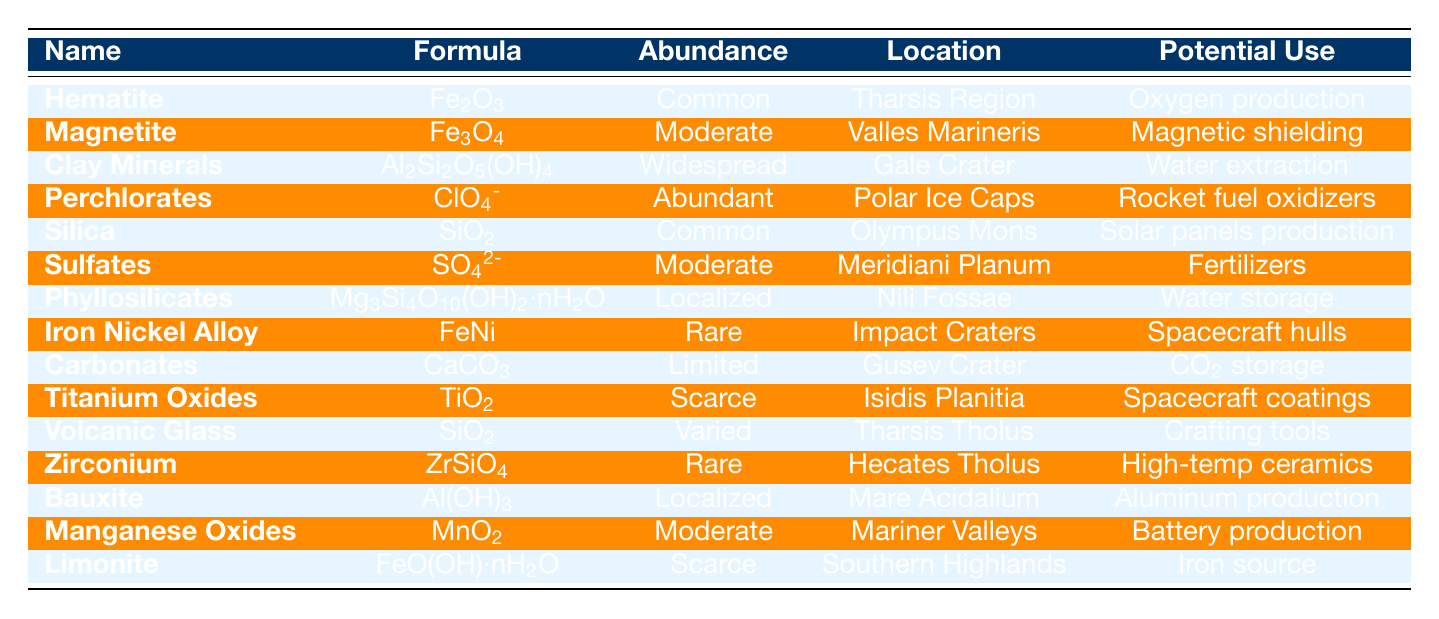What is the chemical formula of Hematite? Look up the row for Hematite in the table, where the chemical formula is listed under the "Formula" column. It reads Fe2O3.
Answer: Fe2O3 Which mineral has the potential use for rocket fuel oxidizers? Check the "Potential Use" column for each mineral and find that Perchlorates is associated with rocket fuel oxidizers.
Answer: Perchlorates Name a mineral found in the Tharsis Region. Look at the "Location" column, and you will see Hematite and Volcanic Glass listed in the Tharsis Region.
Answer: Hematite or Volcanic Glass What is the abundance level of Iron Nickel Alloy? Locate Iron Nickel Alloy in the table and check its "Abundance" column. It states that it is Rare.
Answer: Rare How many minerals have a Moderate abundance level? Count the occurrences of the term "Moderate" found in the "Abundance" column. There are 3 instances: Magnetite, Sulfates, and Manganese Oxides.
Answer: 3 Which mineral located in Gale Crater has the potential for water extraction? Find the row for Gale Crater in the "Location" column and check its "Potential Use." It corresponds to Clay Minerals.
Answer: Clay Minerals Is Limonite found in the Southern Highlands? Check the table to see if Limonite is listed under the "Location" column. It is indeed found in the Southern Highlands.
Answer: Yes What mineral has the potential use for producing solar panels? Look for "solar panels" in the "Potential Use" column, where you will find it associated with Silica.
Answer: Silica Which minerals have limited or scarce abundance? Review the "Abundance" column and identify Carbonates (Limited) and Titanium Oxides, Limonite (Scarce). Those are the minerals fitting this criterion.
Answer: Carbonates and Titanium Oxides, Limonite Determine the total count of minerals used for enhancing water storage. In the "Potential Use" column, check for entries about water storage; only Phyllosilicates is mentioned for this use.
Answer: 1 What is the potential use of Zirconium? Find Zirconium in the table, and look at its "Potential Use," which states it can be used for high-temperature ceramics and nuclear reactors.
Answer: High-temperature ceramics and nuclear reactors How many minerals found in the Polar Ice Caps have abundant availability? Review the "Abundance" column for entries under Polar Ice Caps. Only Perchlorates has an abundance of Abundant. Thus, count it.
Answer: 1 List all minerals that can be used for construction of spacecraft hulls. Search the "Potential Use" column for construction-related uses, and find Iron Nickel Alloy explicitly mentioned for spacecraft hulls.
Answer: Iron Nickel Alloy 